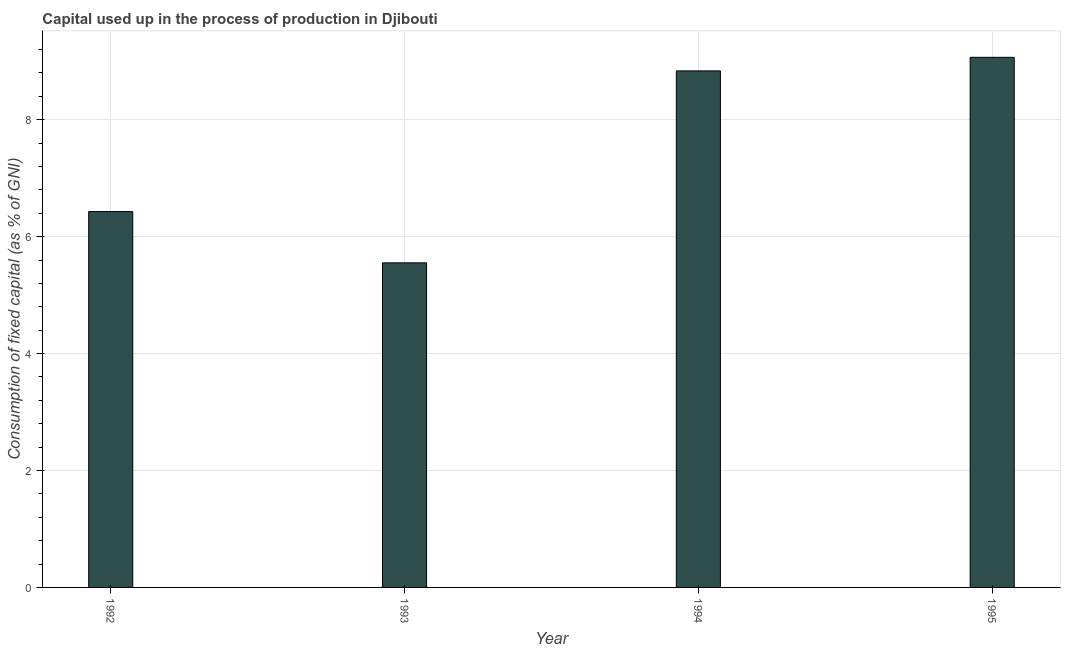Does the graph contain any zero values?
Ensure brevity in your answer.  No. Does the graph contain grids?
Provide a succinct answer. Yes. What is the title of the graph?
Offer a very short reply. Capital used up in the process of production in Djibouti. What is the label or title of the X-axis?
Your answer should be very brief. Year. What is the label or title of the Y-axis?
Make the answer very short. Consumption of fixed capital (as % of GNI). What is the consumption of fixed capital in 1993?
Offer a terse response. 5.55. Across all years, what is the maximum consumption of fixed capital?
Your response must be concise. 9.07. Across all years, what is the minimum consumption of fixed capital?
Your answer should be compact. 5.55. In which year was the consumption of fixed capital maximum?
Provide a short and direct response. 1995. In which year was the consumption of fixed capital minimum?
Provide a short and direct response. 1993. What is the sum of the consumption of fixed capital?
Provide a succinct answer. 29.88. What is the difference between the consumption of fixed capital in 1993 and 1994?
Your answer should be compact. -3.28. What is the average consumption of fixed capital per year?
Your answer should be very brief. 7.47. What is the median consumption of fixed capital?
Keep it short and to the point. 7.63. What is the ratio of the consumption of fixed capital in 1994 to that in 1995?
Ensure brevity in your answer.  0.97. Is the consumption of fixed capital in 1994 less than that in 1995?
Ensure brevity in your answer.  Yes. What is the difference between the highest and the second highest consumption of fixed capital?
Give a very brief answer. 0.23. What is the difference between the highest and the lowest consumption of fixed capital?
Offer a terse response. 3.52. In how many years, is the consumption of fixed capital greater than the average consumption of fixed capital taken over all years?
Provide a succinct answer. 2. How many bars are there?
Your answer should be very brief. 4. What is the Consumption of fixed capital (as % of GNI) in 1992?
Keep it short and to the point. 6.43. What is the Consumption of fixed capital (as % of GNI) in 1993?
Offer a terse response. 5.55. What is the Consumption of fixed capital (as % of GNI) in 1994?
Your response must be concise. 8.84. What is the Consumption of fixed capital (as % of GNI) of 1995?
Make the answer very short. 9.07. What is the difference between the Consumption of fixed capital (as % of GNI) in 1992 and 1993?
Provide a short and direct response. 0.88. What is the difference between the Consumption of fixed capital (as % of GNI) in 1992 and 1994?
Your response must be concise. -2.41. What is the difference between the Consumption of fixed capital (as % of GNI) in 1992 and 1995?
Offer a very short reply. -2.64. What is the difference between the Consumption of fixed capital (as % of GNI) in 1993 and 1994?
Your answer should be compact. -3.28. What is the difference between the Consumption of fixed capital (as % of GNI) in 1993 and 1995?
Provide a short and direct response. -3.52. What is the difference between the Consumption of fixed capital (as % of GNI) in 1994 and 1995?
Offer a terse response. -0.23. What is the ratio of the Consumption of fixed capital (as % of GNI) in 1992 to that in 1993?
Your response must be concise. 1.16. What is the ratio of the Consumption of fixed capital (as % of GNI) in 1992 to that in 1994?
Provide a short and direct response. 0.73. What is the ratio of the Consumption of fixed capital (as % of GNI) in 1992 to that in 1995?
Keep it short and to the point. 0.71. What is the ratio of the Consumption of fixed capital (as % of GNI) in 1993 to that in 1994?
Offer a terse response. 0.63. What is the ratio of the Consumption of fixed capital (as % of GNI) in 1993 to that in 1995?
Your answer should be compact. 0.61. 